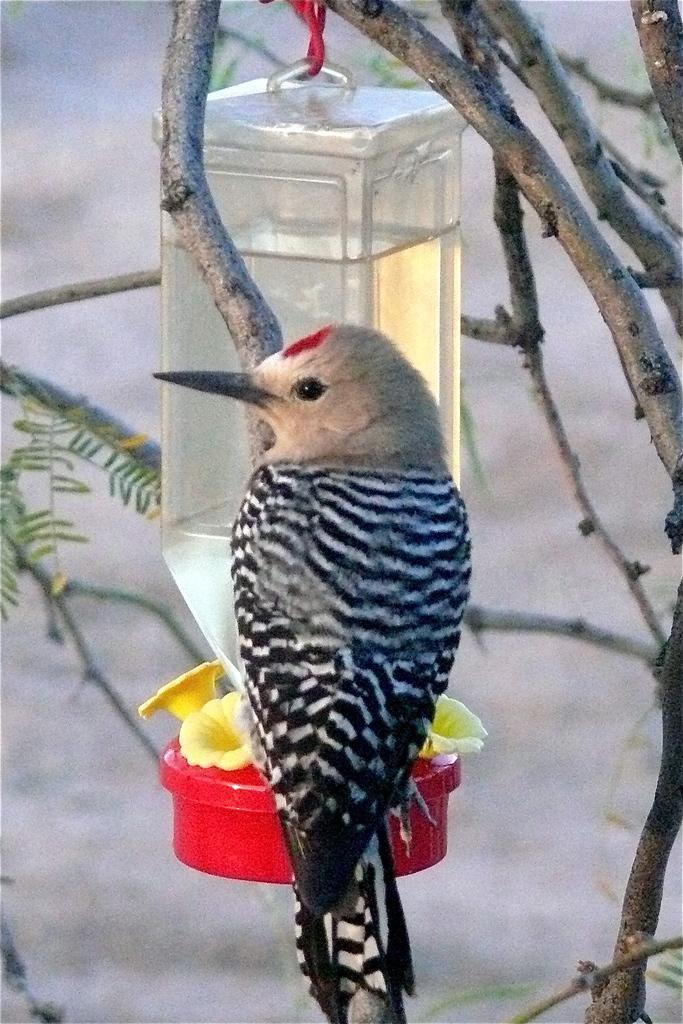In one or two sentences, can you explain what this image depicts? In this image we can see a bird which is on the branch of a tree and there is a bottle in which there are some water which is hanged to the branch of a tree. 